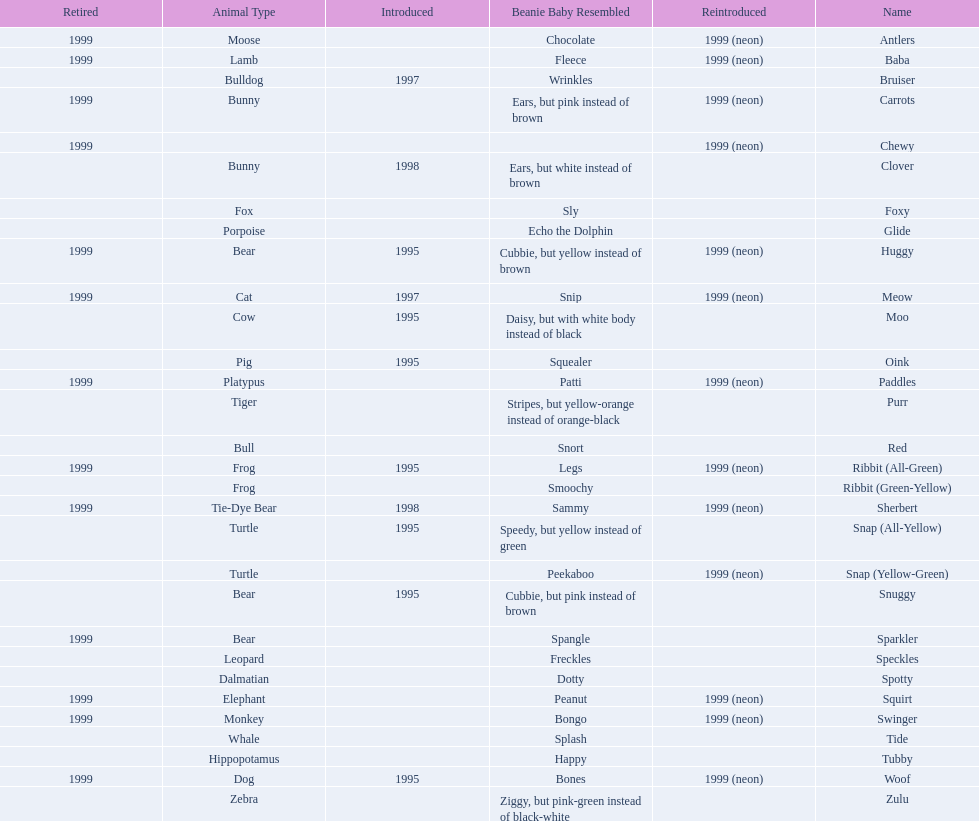Could you help me parse every detail presented in this table? {'header': ['Retired', 'Animal Type', 'Introduced', 'Beanie Baby Resembled', 'Reintroduced', 'Name'], 'rows': [['1999', 'Moose', '', 'Chocolate', '1999 (neon)', 'Antlers'], ['1999', 'Lamb', '', 'Fleece', '1999 (neon)', 'Baba'], ['', 'Bulldog', '1997', 'Wrinkles', '', 'Bruiser'], ['1999', 'Bunny', '', 'Ears, but pink instead of brown', '1999 (neon)', 'Carrots'], ['1999', '', '', '', '1999 (neon)', 'Chewy'], ['', 'Bunny', '1998', 'Ears, but white instead of brown', '', 'Clover'], ['', 'Fox', '', 'Sly', '', 'Foxy'], ['', 'Porpoise', '', 'Echo the Dolphin', '', 'Glide'], ['1999', 'Bear', '1995', 'Cubbie, but yellow instead of brown', '1999 (neon)', 'Huggy'], ['1999', 'Cat', '1997', 'Snip', '1999 (neon)', 'Meow'], ['', 'Cow', '1995', 'Daisy, but with white body instead of black', '', 'Moo'], ['', 'Pig', '1995', 'Squealer', '', 'Oink'], ['1999', 'Platypus', '', 'Patti', '1999 (neon)', 'Paddles'], ['', 'Tiger', '', 'Stripes, but yellow-orange instead of orange-black', '', 'Purr'], ['', 'Bull', '', 'Snort', '', 'Red'], ['1999', 'Frog', '1995', 'Legs', '1999 (neon)', 'Ribbit (All-Green)'], ['', 'Frog', '', 'Smoochy', '', 'Ribbit (Green-Yellow)'], ['1999', 'Tie-Dye Bear', '1998', 'Sammy', '1999 (neon)', 'Sherbert'], ['', 'Turtle', '1995', 'Speedy, but yellow instead of green', '', 'Snap (All-Yellow)'], ['', 'Turtle', '', 'Peekaboo', '1999 (neon)', 'Snap (Yellow-Green)'], ['', 'Bear', '1995', 'Cubbie, but pink instead of brown', '', 'Snuggy'], ['1999', 'Bear', '', 'Spangle', '', 'Sparkler'], ['', 'Leopard', '', 'Freckles', '', 'Speckles'], ['', 'Dalmatian', '', 'Dotty', '', 'Spotty'], ['1999', 'Elephant', '', 'Peanut', '1999 (neon)', 'Squirt'], ['1999', 'Monkey', '', 'Bongo', '1999 (neon)', 'Swinger'], ['', 'Whale', '', 'Splash', '', 'Tide'], ['', 'Hippopotamus', '', 'Happy', '', 'Tubby'], ['1999', 'Dog', '1995', 'Bones', '1999 (neon)', 'Woof'], ['', 'Zebra', '', 'Ziggy, but pink-green instead of black-white', '', 'Zulu']]} Tell me the number of pillow pals reintroduced in 1999. 13. 